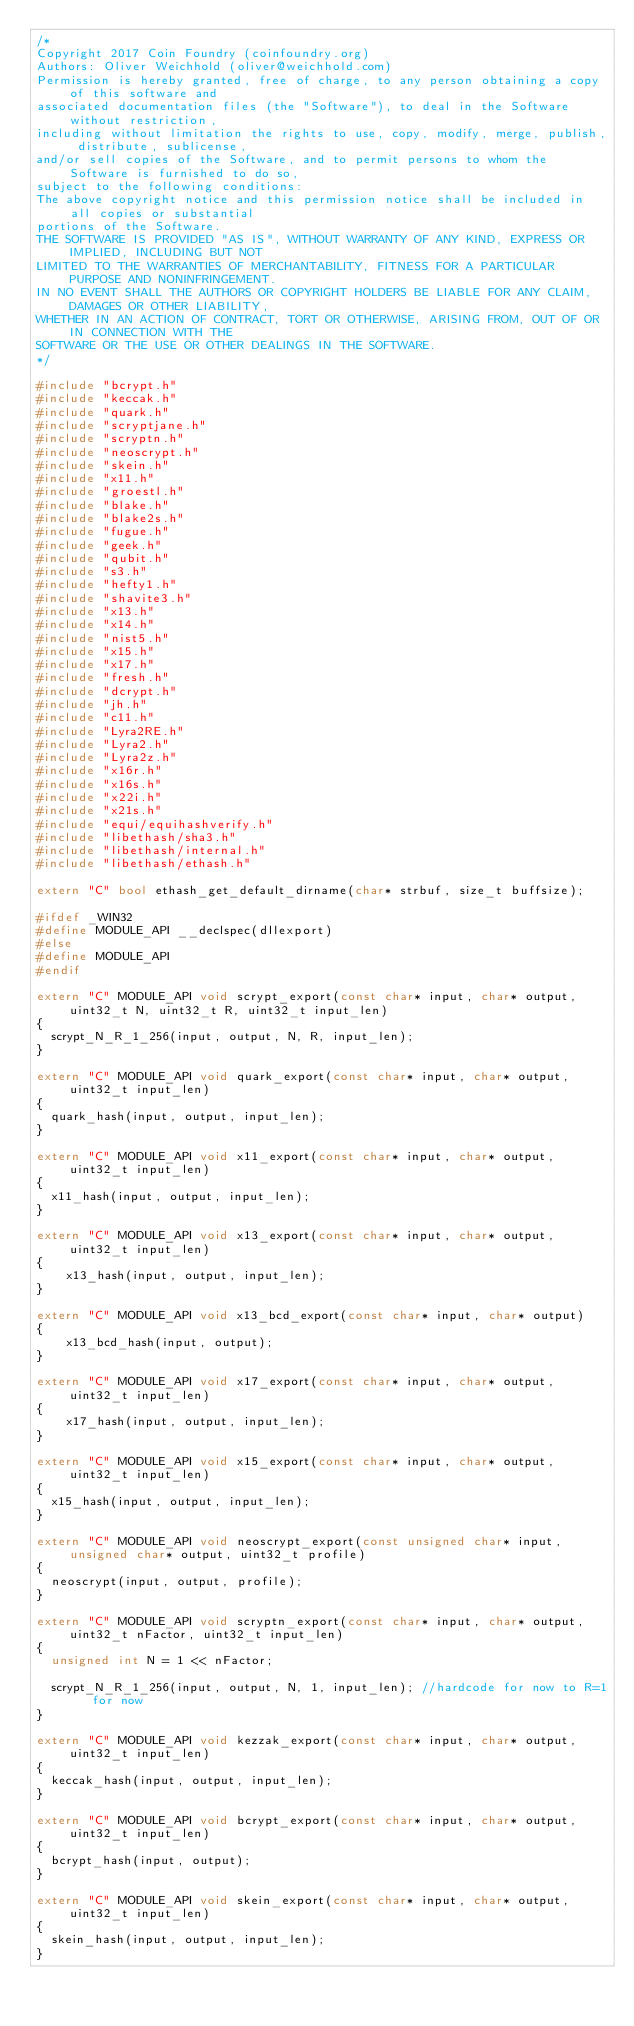Convert code to text. <code><loc_0><loc_0><loc_500><loc_500><_C++_>/*
Copyright 2017 Coin Foundry (coinfoundry.org)
Authors: Oliver Weichhold (oliver@weichhold.com)
Permission is hereby granted, free of charge, to any person obtaining a copy of this software and
associated documentation files (the "Software"), to deal in the Software without restriction,
including without limitation the rights to use, copy, modify, merge, publish, distribute, sublicense,
and/or sell copies of the Software, and to permit persons to whom the Software is furnished to do so,
subject to the following conditions:
The above copyright notice and this permission notice shall be included in all copies or substantial
portions of the Software.
THE SOFTWARE IS PROVIDED "AS IS", WITHOUT WARRANTY OF ANY KIND, EXPRESS OR IMPLIED, INCLUDING BUT NOT
LIMITED TO THE WARRANTIES OF MERCHANTABILITY, FITNESS FOR A PARTICULAR PURPOSE AND NONINFRINGEMENT.
IN NO EVENT SHALL THE AUTHORS OR COPYRIGHT HOLDERS BE LIABLE FOR ANY CLAIM, DAMAGES OR OTHER LIABILITY,
WHETHER IN AN ACTION OF CONTRACT, TORT OR OTHERWISE, ARISING FROM, OUT OF OR IN CONNECTION WITH THE
SOFTWARE OR THE USE OR OTHER DEALINGS IN THE SOFTWARE.
*/

#include "bcrypt.h"
#include "keccak.h"
#include "quark.h"
#include "scryptjane.h"
#include "scryptn.h"
#include "neoscrypt.h"
#include "skein.h"
#include "x11.h"
#include "groestl.h"
#include "blake.h"
#include "blake2s.h"
#include "fugue.h"
#include "geek.h"
#include "qubit.h"
#include "s3.h"
#include "hefty1.h"
#include "shavite3.h"
#include "x13.h"
#include "x14.h"
#include "nist5.h"
#include "x15.h"
#include "x17.h"
#include "fresh.h"
#include "dcrypt.h"
#include "jh.h"
#include "c11.h"
#include "Lyra2RE.h"
#include "Lyra2.h"
#include "Lyra2z.h"
#include "x16r.h"
#include "x16s.h"
#include "x22i.h"
#include "x21s.h"
#include "equi/equihashverify.h"
#include "libethash/sha3.h"
#include "libethash/internal.h"
#include "libethash/ethash.h"

extern "C" bool ethash_get_default_dirname(char* strbuf, size_t buffsize);

#ifdef _WIN32
#define MODULE_API __declspec(dllexport)
#else
#define MODULE_API
#endif

extern "C" MODULE_API void scrypt_export(const char* input, char* output, uint32_t N, uint32_t R, uint32_t input_len)
{
	scrypt_N_R_1_256(input, output, N, R, input_len);
}

extern "C" MODULE_API void quark_export(const char* input, char* output, uint32_t input_len)
{
	quark_hash(input, output, input_len);
}

extern "C" MODULE_API void x11_export(const char* input, char* output, uint32_t input_len)
{
	x11_hash(input, output, input_len);
}

extern "C" MODULE_API void x13_export(const char* input, char* output, uint32_t input_len)
{
    x13_hash(input, output, input_len);
}

extern "C" MODULE_API void x13_bcd_export(const char* input, char* output)
{
    x13_bcd_hash(input, output);
}

extern "C" MODULE_API void x17_export(const char* input, char* output, uint32_t input_len)
{
    x17_hash(input, output, input_len);
}

extern "C" MODULE_API void x15_export(const char* input, char* output, uint32_t input_len)
{
	x15_hash(input, output, input_len);
}

extern "C" MODULE_API void neoscrypt_export(const unsigned char* input, unsigned char* output, uint32_t profile)
{
	neoscrypt(input, output, profile);
}

extern "C" MODULE_API void scryptn_export(const char* input, char* output, uint32_t nFactor, uint32_t input_len)
{
	unsigned int N = 1 << nFactor;

	scrypt_N_R_1_256(input, output, N, 1, input_len); //hardcode for now to R=1 for now
}

extern "C" MODULE_API void kezzak_export(const char* input, char* output, uint32_t input_len)
{
	keccak_hash(input, output, input_len);
}

extern "C" MODULE_API void bcrypt_export(const char* input, char* output, uint32_t input_len)
{
	bcrypt_hash(input, output);
}

extern "C" MODULE_API void skein_export(const char* input, char* output, uint32_t input_len)
{
	skein_hash(input, output, input_len);
}
</code> 